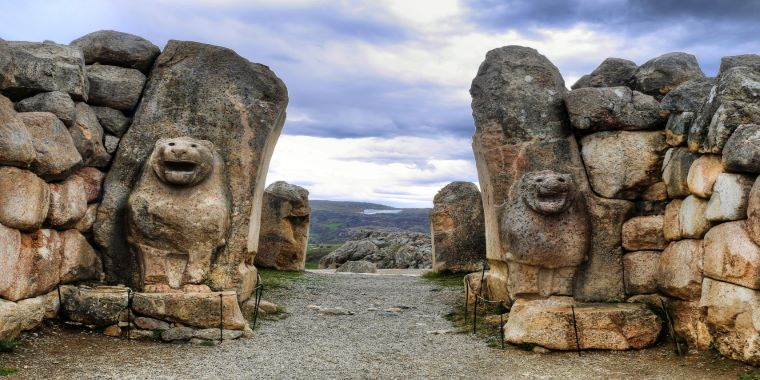Analyze the image in a comprehensive and detailed manner. The image captures the historic Lion Gate at Hattusa, an ancient city of the Hittites, located in modern-day Turkey. This grand gate is constructed from large, well-fitted stones and features two prominent lion sculptures carved from the sharegpt4v/same stone, standing as silent guardians. The lions possess a distinct sense of vigilance and strength, their features meticulously detailed, indicative of the Hittites' advanced sculpting skills. The gate opens up to a rugged landscape framed by distant mountains and a sky adorned with rolling clouds, contributing to a dramatic and timeless scene. The image, likely taken from a low angle, enhances the monumental scale and grandeur of this ancient structure, making it an awe-inspiring representation of Turkey's rich archaeological and cultural heritage. In essence, this image not only highlights the architectural prowess of an ancient civilization but also serves as a window into the past, allowing us to admire the artistry and historical significance of the Lion Gate. 